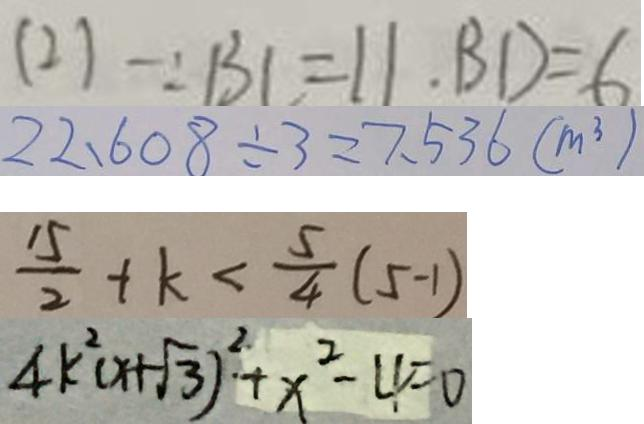<formula> <loc_0><loc_0><loc_500><loc_500>( 2 ) \because B C = 1 1 . \cdot B D = 6 
 2 2 . 6 0 8 \div 3 = 7 . 5 3 6 ( m ^ { 3 } ) 
 \frac { 1 5 } { 2 } + k < \frac { 5 } { 4 } ( 5 - 1 ) 
 4 k ^ { 2 } ( x + \sqrt { 3 } ) ^ { 2 } + x ^ { 2 } - 4 = 0</formula> 